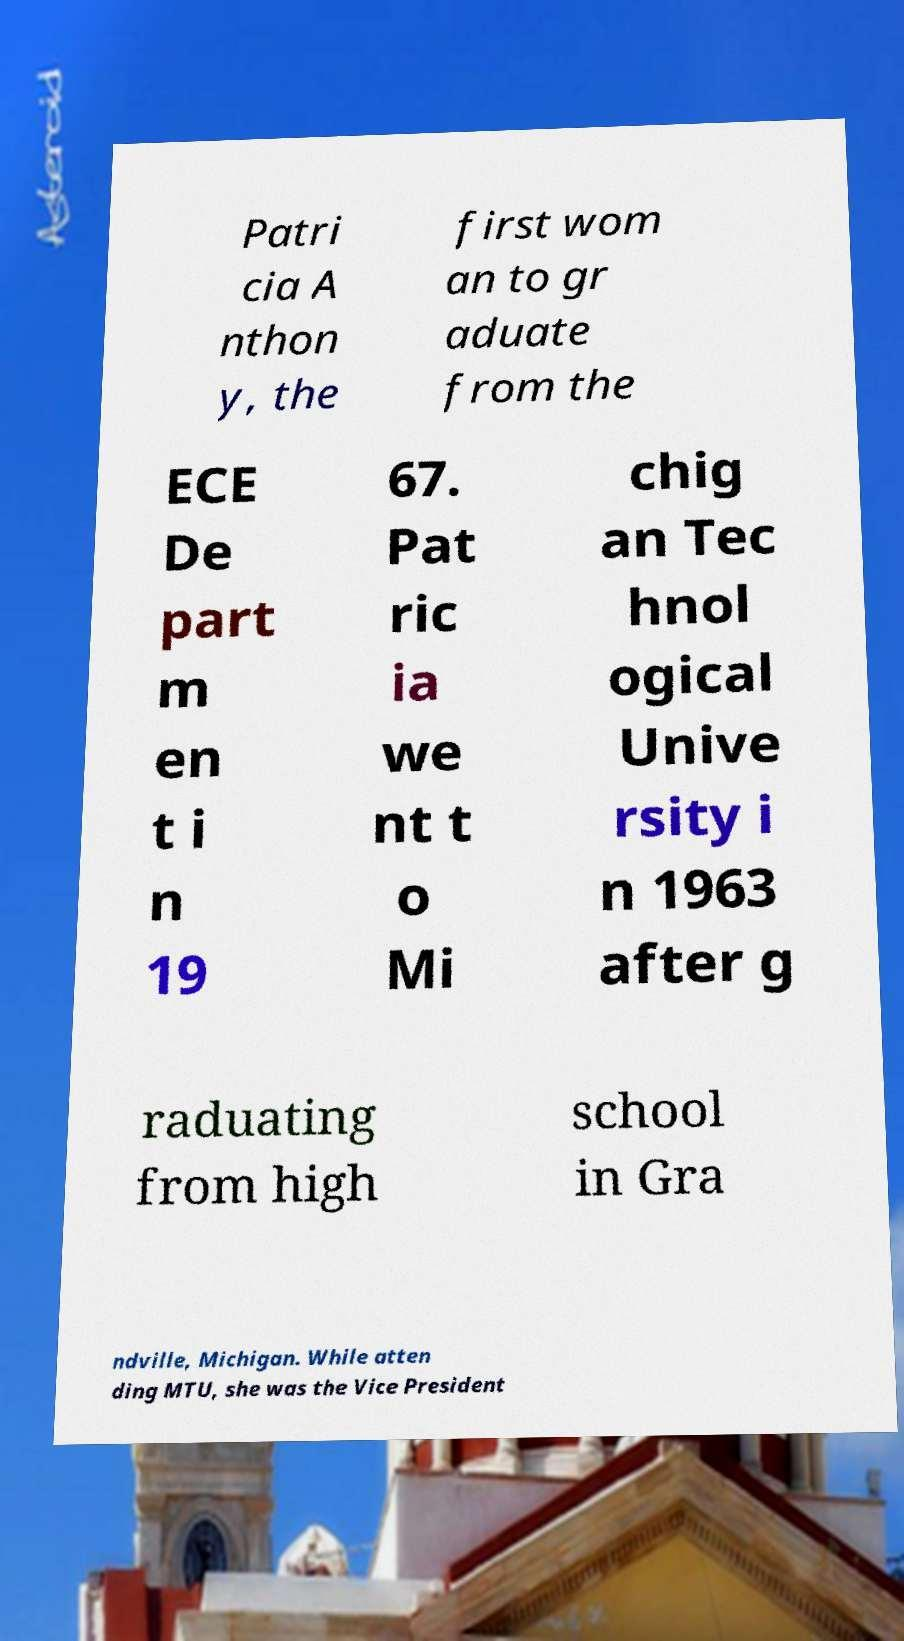Could you assist in decoding the text presented in this image and type it out clearly? Patri cia A nthon y, the first wom an to gr aduate from the ECE De part m en t i n 19 67. Pat ric ia we nt t o Mi chig an Tec hnol ogical Unive rsity i n 1963 after g raduating from high school in Gra ndville, Michigan. While atten ding MTU, she was the Vice President 